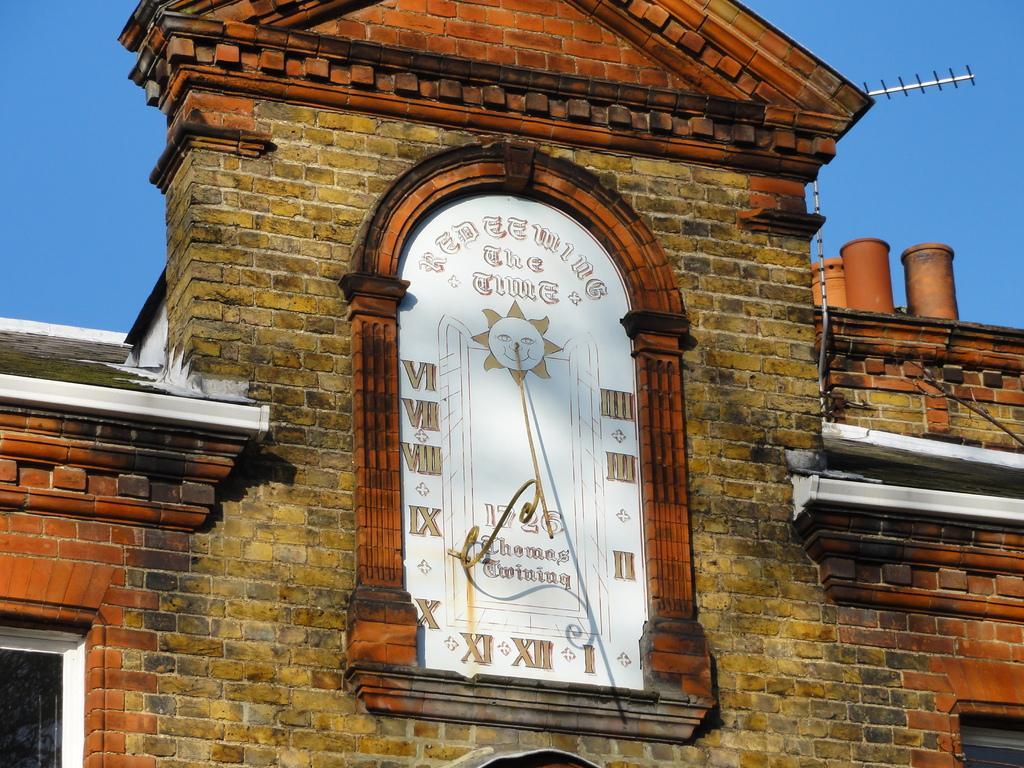<image>
Create a compact narrative representing the image presented. An old clock with roman numerals on it within an old brick building 